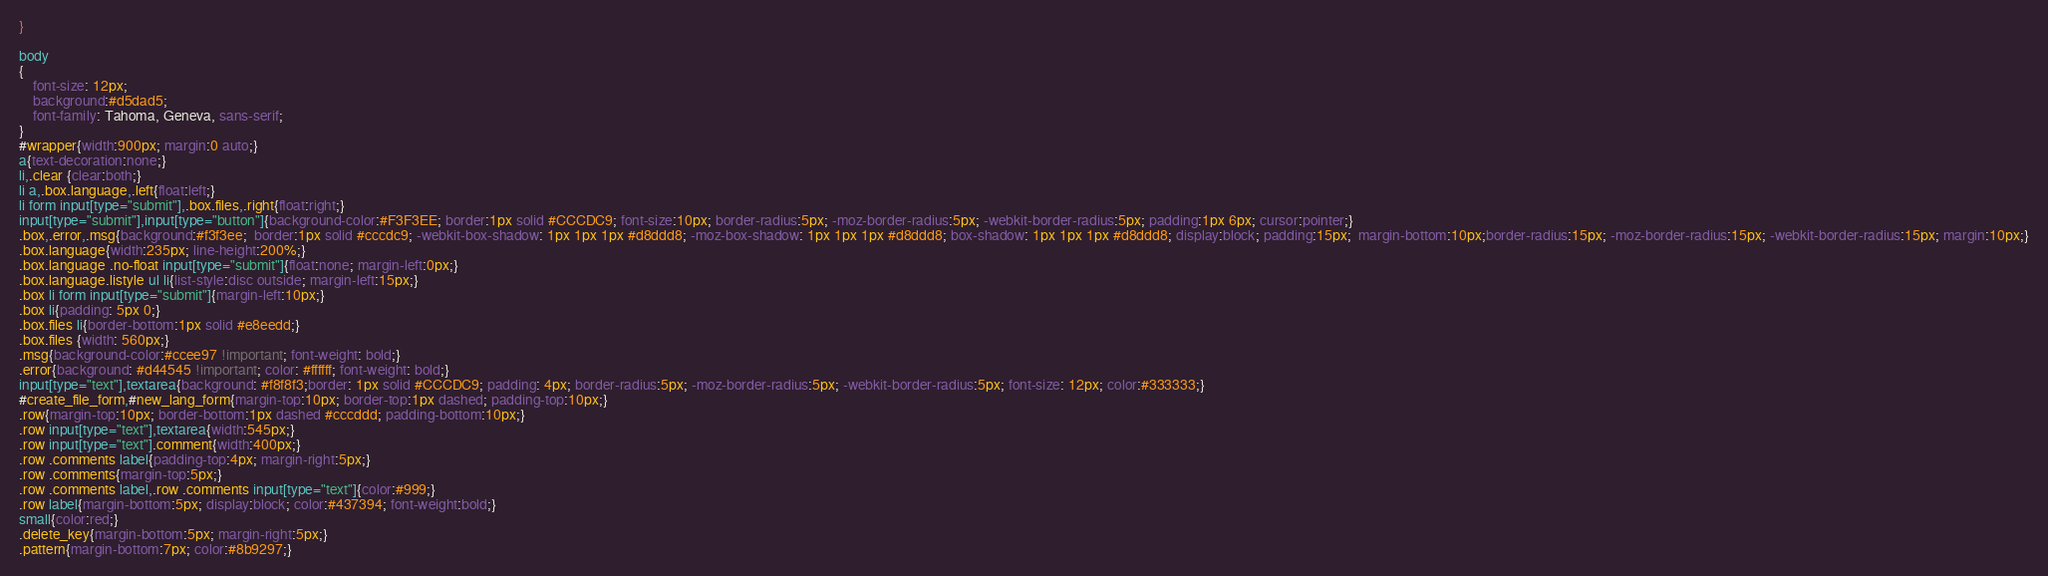<code> <loc_0><loc_0><loc_500><loc_500><_CSS_>}

body 
{
	font-size: 12px;
	background:#d5dad5;
	font-family: Tahoma, Geneva, sans-serif;
}
#wrapper{width:900px; margin:0 auto;}
a{text-decoration:none;}
li,.clear {clear:both;}
li a,.box.language,.left{float:left;}
li form input[type="submit"],.box.files,.right{float:right;}
input[type="submit"],input[type="button"]{background-color:#F3F3EE; border:1px solid #CCCDC9; font-size:10px; border-radius:5px; -moz-border-radius:5px; -webkit-border-radius:5px; padding:1px 6px; cursor:pointer;}
.box,.error,.msg{background:#f3f3ee;  border:1px solid #cccdc9; -webkit-box-shadow: 1px 1px 1px #d8ddd8; -moz-box-shadow: 1px 1px 1px #d8ddd8; box-shadow: 1px 1px 1px #d8ddd8; display:block; padding:15px;  margin-bottom:10px;border-radius:15px; -moz-border-radius:15px; -webkit-border-radius:15px; margin:10px;}
.box.language{width:235px; line-height:200%;}
.box.language .no-float input[type="submit"]{float:none; margin-left:0px;}
.box.language.listyle ul li{list-style:disc outside; margin-left:15px;}
.box li form input[type="submit"]{margin-left:10px;}
.box li{padding: 5px 0;}
.box.files li{border-bottom:1px solid #e8eedd;}
.box.files {width: 560px;}
.msg{background-color:#ccee97 !important; font-weight: bold;}
.error{background: #d44545 !important; color: #ffffff; font-weight: bold;}
input[type="text"],textarea{background: #f8f8f3;border: 1px solid #CCCDC9; padding: 4px; border-radius:5px; -moz-border-radius:5px; -webkit-border-radius:5px; font-size: 12px; color:#333333;}
#create_file_form,#new_lang_form{margin-top:10px; border-top:1px dashed; padding-top:10px;}
.row{margin-top:10px; border-bottom:1px dashed #cccddd; padding-bottom:10px;}
.row input[type="text"],textarea{width:545px;}
.row input[type="text"].comment{width:400px;}
.row .comments label{padding-top:4px; margin-right:5px;}
.row .comments{margin-top:5px;}
.row .comments label,.row .comments input[type="text"]{color:#999;}
.row label{margin-bottom:5px; display:block; color:#437394; font-weight:bold;}
small{color:red;}
.delete_key{margin-bottom:5px; margin-right:5px;}
.pattern{margin-bottom:7px; color:#8b9297;}
</code> 